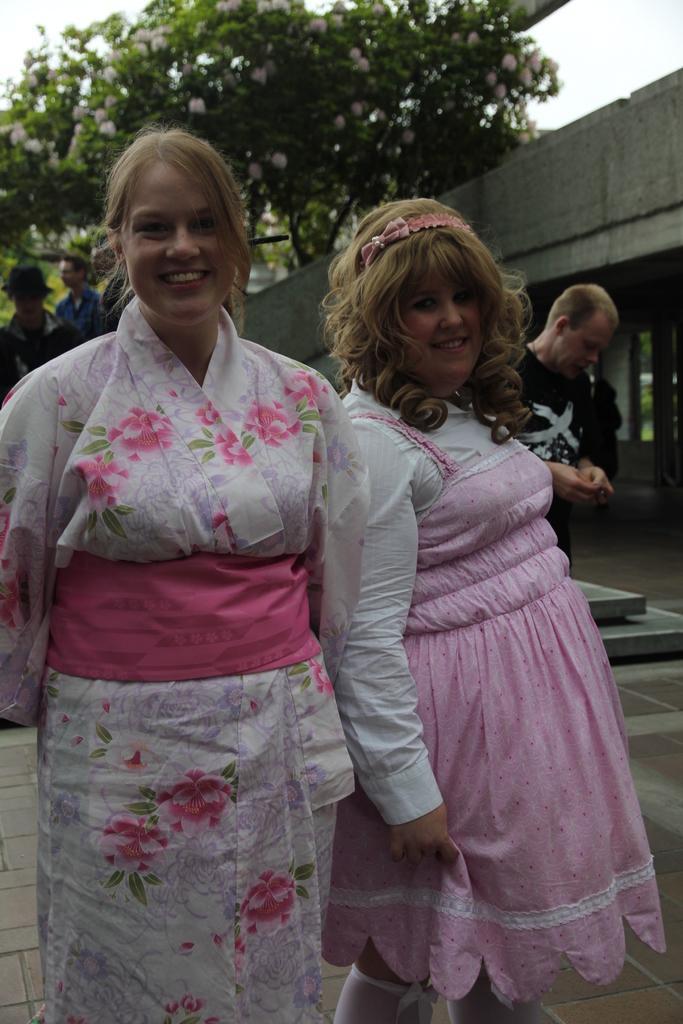How would you summarize this image in a sentence or two? In this image, we can see a few people. We can also see the ground. There are some trees with flowers. On the top right, we can also see a wall and the sky. 